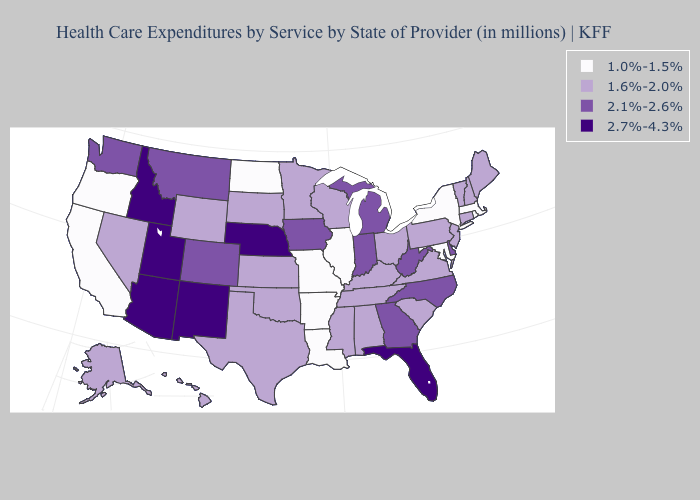What is the value of New Jersey?
Write a very short answer. 1.6%-2.0%. Does Wyoming have the highest value in the West?
Short answer required. No. What is the value of Alaska?
Short answer required. 1.6%-2.0%. Does New Mexico have the highest value in the USA?
Keep it brief. Yes. Which states hav the highest value in the MidWest?
Keep it brief. Nebraska. Does North Carolina have the same value as Georgia?
Keep it brief. Yes. How many symbols are there in the legend?
Quick response, please. 4. Name the states that have a value in the range 2.7%-4.3%?
Concise answer only. Arizona, Florida, Idaho, Nebraska, New Mexico, Utah. What is the value of North Carolina?
Quick response, please. 2.1%-2.6%. Among the states that border West Virginia , which have the highest value?
Short answer required. Kentucky, Ohio, Pennsylvania, Virginia. Which states have the lowest value in the West?
Keep it brief. California, Oregon. What is the lowest value in the USA?
Keep it brief. 1.0%-1.5%. Does Kansas have the lowest value in the USA?
Give a very brief answer. No. Name the states that have a value in the range 2.1%-2.6%?
Answer briefly. Colorado, Delaware, Georgia, Indiana, Iowa, Michigan, Montana, North Carolina, Washington, West Virginia. What is the value of Kentucky?
Concise answer only. 1.6%-2.0%. 